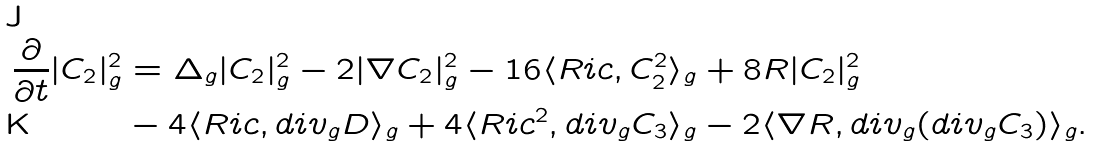<formula> <loc_0><loc_0><loc_500><loc_500>\frac { \partial } { \partial t } | C _ { 2 } | ^ { 2 } _ { g } & = \Delta _ { g } | C _ { 2 } | ^ { 2 } _ { g } - 2 | \nabla C _ { 2 } | ^ { 2 } _ { g } - 1 6 \langle R i c , C ^ { 2 } _ { 2 } \rangle _ { g } + 8 R | C _ { 2 } | _ { g } ^ { 2 } \\ & - 4 \langle R i c , d i v _ { g } D \rangle _ { g } + 4 \langle R i c ^ { 2 } , d i v _ { g } C _ { 3 } \rangle _ { g } - 2 \langle \nabla R , d i v _ { g } ( d i v _ { g } C _ { 3 } ) \rangle _ { g } .</formula> 